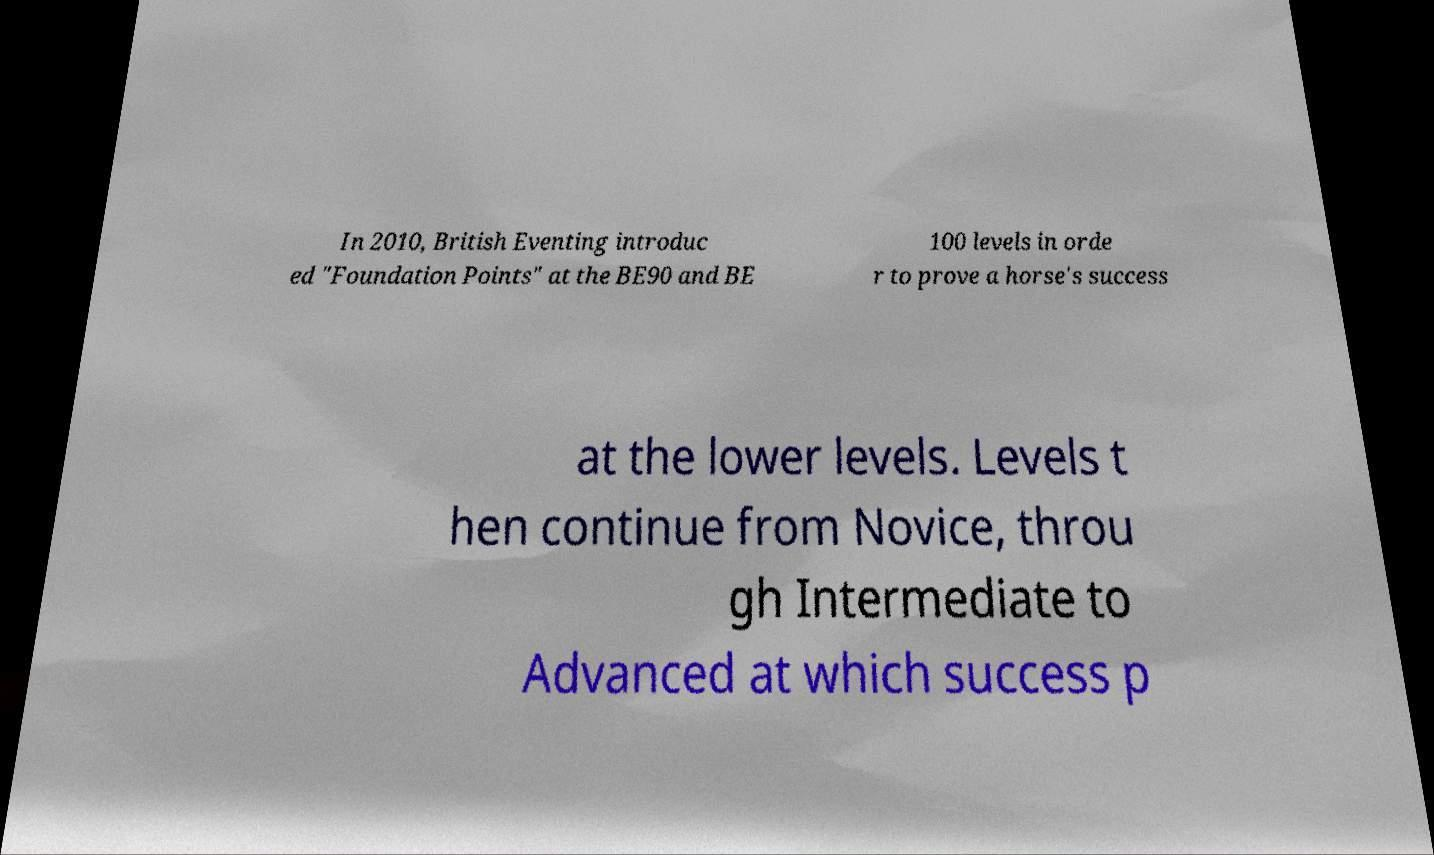Could you extract and type out the text from this image? In 2010, British Eventing introduc ed "Foundation Points" at the BE90 and BE 100 levels in orde r to prove a horse's success at the lower levels. Levels t hen continue from Novice, throu gh Intermediate to Advanced at which success p 